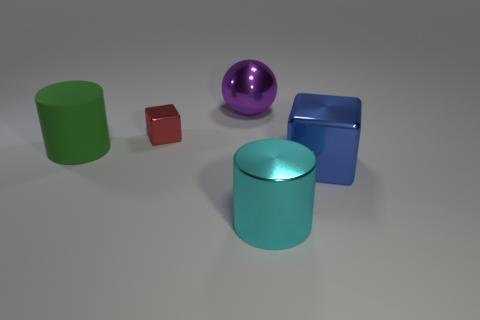What material is the large blue object that is the same shape as the red thing?
Your answer should be compact. Metal. Is there anything else that is the same shape as the large blue metallic object?
Offer a very short reply. Yes. There is a block in front of the small red metal cube; what is its size?
Your answer should be very brief. Large. How many other objects are the same color as the tiny thing?
Make the answer very short. 0. What material is the cylinder in front of the large cylinder left of the red metal object?
Ensure brevity in your answer.  Metal. Are there any other things that have the same material as the green thing?
Provide a short and direct response. No. How many other big cyan objects are the same shape as the rubber object?
Your answer should be compact. 1. What is the size of the sphere that is the same material as the blue thing?
Make the answer very short. Large. There is a large cylinder that is in front of the big thing to the right of the cyan shiny cylinder; are there any metallic objects behind it?
Your answer should be compact. Yes. Does the shiny cube that is in front of the green cylinder have the same size as the purple object?
Your answer should be compact. Yes. 